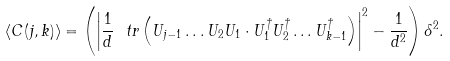Convert formula to latex. <formula><loc_0><loc_0><loc_500><loc_500>\langle C ( j , k ) \rangle = \left ( \left | \frac { 1 } { d } \ t r \left ( U _ { j - 1 } \dots U _ { 2 } U _ { 1 } \cdot U ^ { \dagger } _ { 1 } U ^ { \dagger } _ { 2 } \dots U ^ { \dagger } _ { k - 1 } \right ) \right | ^ { 2 } - \frac { 1 } { d ^ { 2 } } \right ) \delta ^ { 2 } .</formula> 